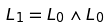<formula> <loc_0><loc_0><loc_500><loc_500>L _ { 1 } = L _ { 0 } \wedge L _ { 0 }</formula> 